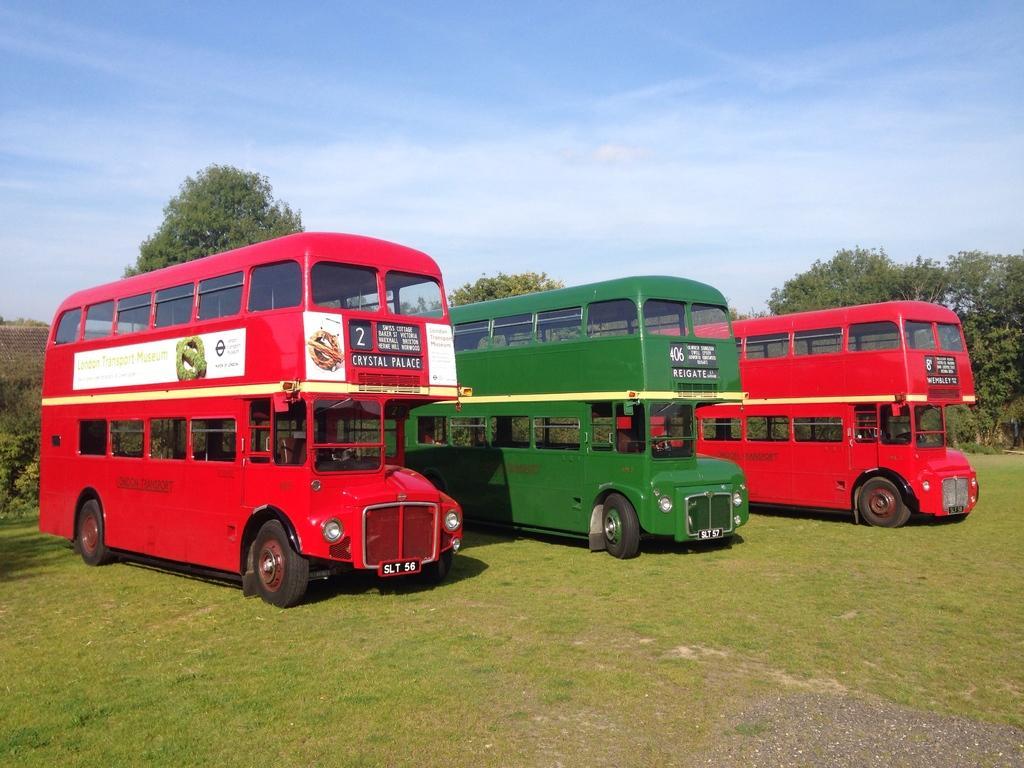Can you describe this image briefly? In this image we can see three double Decker buses. Two are in red color and one is in green color. Background of the image trees are present. The sky is in blue color. Bottom of the image land with small grass is there. 